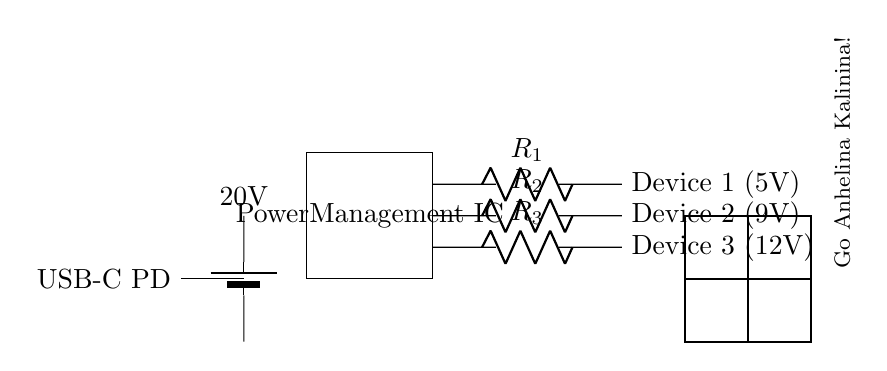What does USB-C PD stand for? USB-C PD stands for Universal Serial Bus Type-C Power Delivery, which is a protocol that allows for faster and flexible power transfer between devices.
Answer: Universal Serial Bus Type-C Power Delivery What are the output voltages for Device 1, Device 2, and Device 3? The output voltage for Device 1 is 5V, for Device 2 is 9V, and for Device 3 is 12V. Each voltage is indicated next to the respective device in the circuit.
Answer: 5V, 9V, 12V What component is used to manage power distribution? The component used to manage power distribution is the Power Management IC. It regulates the voltage outputs to match the needs of the connected devices.
Answer: Power Management IC What is the purpose of the resistors in the circuit? The purpose of the resistors (R1, R2, R3) is to limit the current flowing to each device and ensure the devices receive the correct voltage levels as per their specifications.
Answer: Limit current How many devices can be charged simultaneously in this circuit? Three devices can be charged simultaneously, as indicated by the three output connections from the Power Management IC to Device 1, Device 2, and Device 3.
Answer: Three devices If the input voltage is 20 volts, what is the significance of this voltage? The input voltage of 20 volts is significant as it is the source voltage being converted through the Power Management IC to supply the required lower voltages for the devices.
Answer: Source voltage 